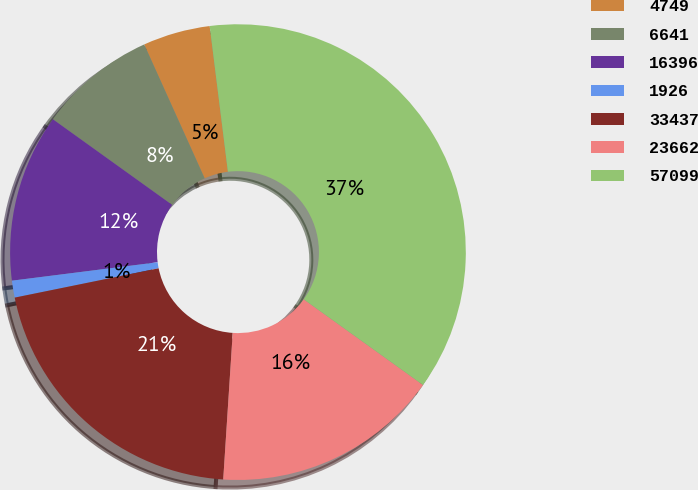Convert chart. <chart><loc_0><loc_0><loc_500><loc_500><pie_chart><fcel>4749<fcel>6641<fcel>16396<fcel>1926<fcel>33437<fcel>23662<fcel>57099<nl><fcel>4.77%<fcel>8.34%<fcel>11.91%<fcel>1.2%<fcel>20.77%<fcel>16.12%<fcel>36.89%<nl></chart> 